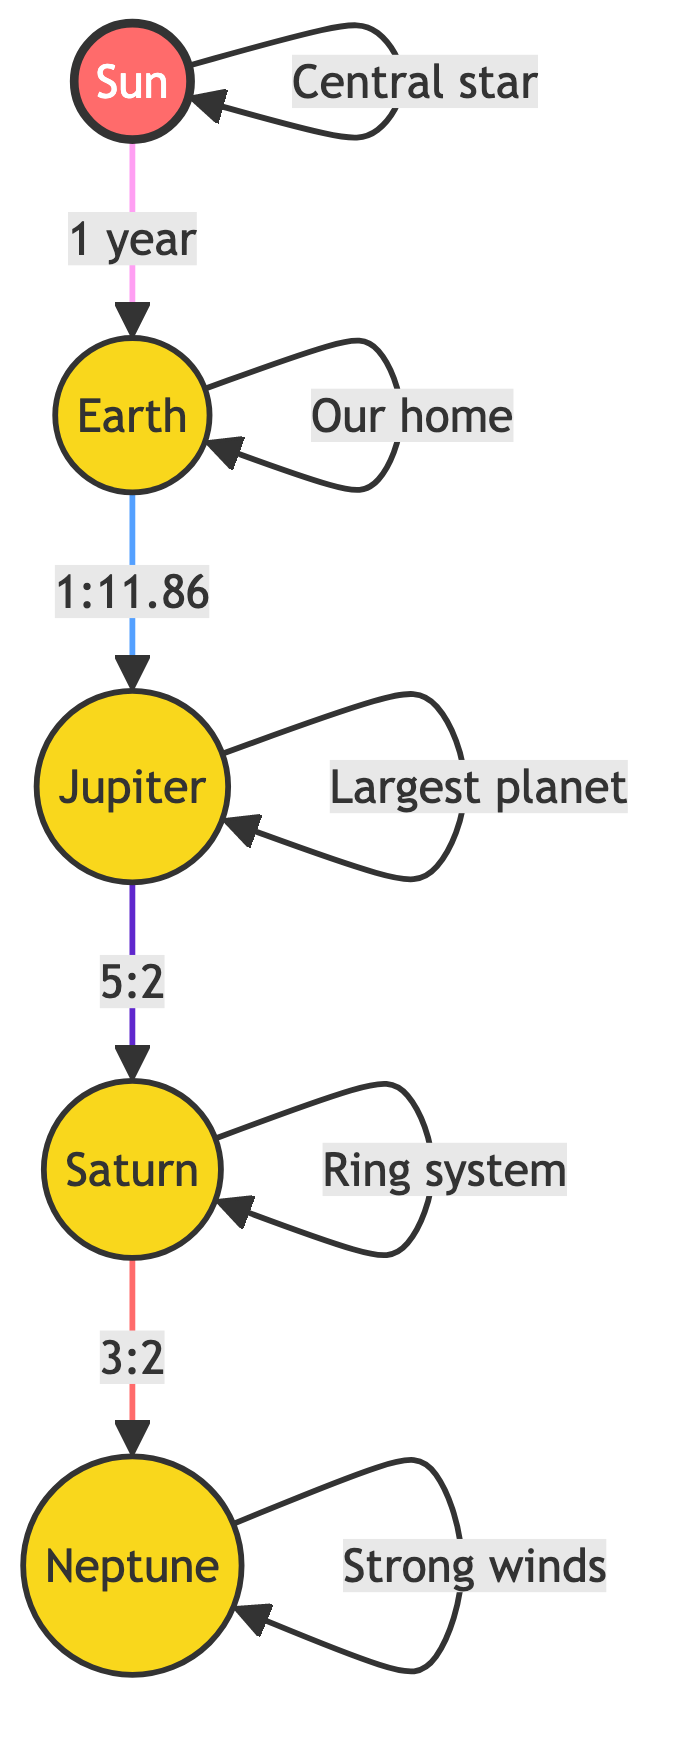What is the orbital period of Earth? The diagram states that the orbital period of Earth is given as "1 year", which is directly linked to the Sun.
Answer: 1 year Which planet has the largest orbital ratio with Earth? Examining the connections, the diagram shows that Jupiter has an orbital ratio of "1:11.86" with Earth, which is the largest among the listed planets.
Answer: Jupiter How many planets are linked to the Sun in this diagram? The diagram shows a total of five nodes connected directly to the Sun (including the Sun itself), counting Earth, Jupiter, Saturn, and Neptune.
Answer: 5 What is the resonance ratio between Jupiter and Saturn? The diagram indicates a resonance ratio of "5:2" between Jupiter and Saturn. This means they exhibit a specific ratio in their orbital periods.
Answer: 5:2 If Saturn's orbital period is a specific time ratio with Neptune, what is that ratio? The diagram shows a resonance ratio of "3:2" between Saturn and Neptune, indicating that for every three orbits of Saturn, Neptune completes two.
Answer: 3:2 Which planet is described with the phrase "Ring system"? The diagram labels Saturn directly with the phrase "Ring system" explaining its prominent characteristic.
Answer: Saturn What is the nature of the winds on Neptune? According to the diagram, Neptune is labeled with "Strong winds", specifying a characteristic feature of this planet.
Answer: Strong winds What is the central star in this diagram? The diagram labels the Sun as "Central star", indicating its role in the solar system depicted.
Answer: Sun Which planet is labeled as "Our home"? From the diagram, Earth is designated as "Our home", reflecting its importance to humanity.
Answer: Earth 